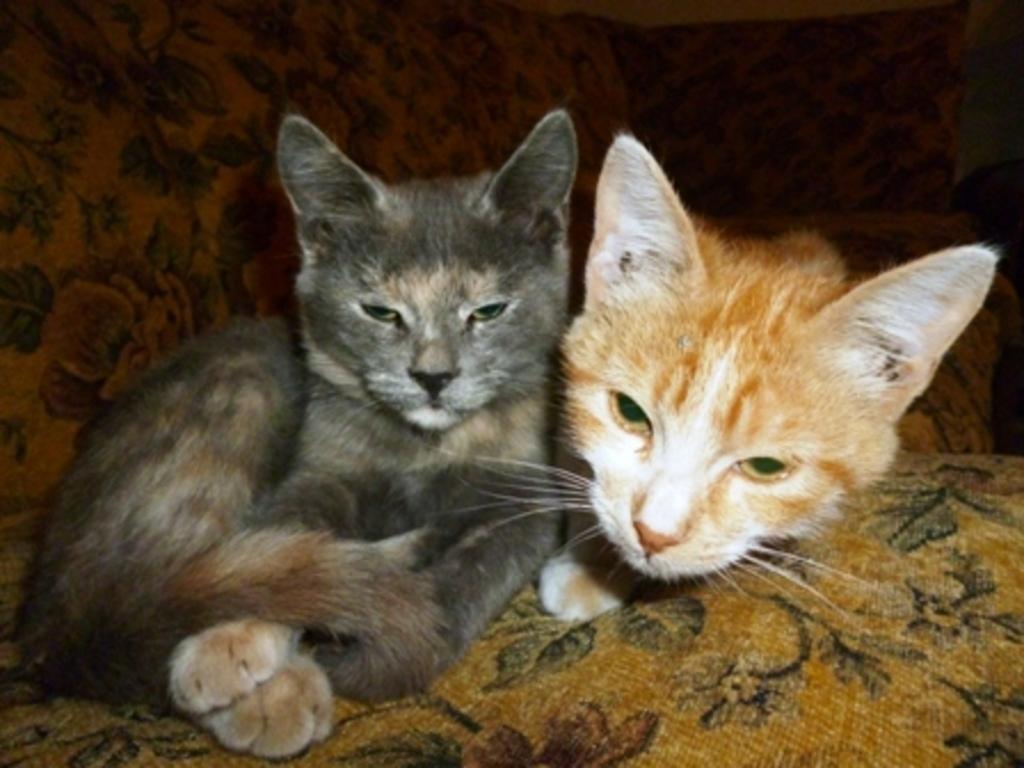Please provide a concise description of this image. In the center of the picture there are two cats. The cats are on a couch. 